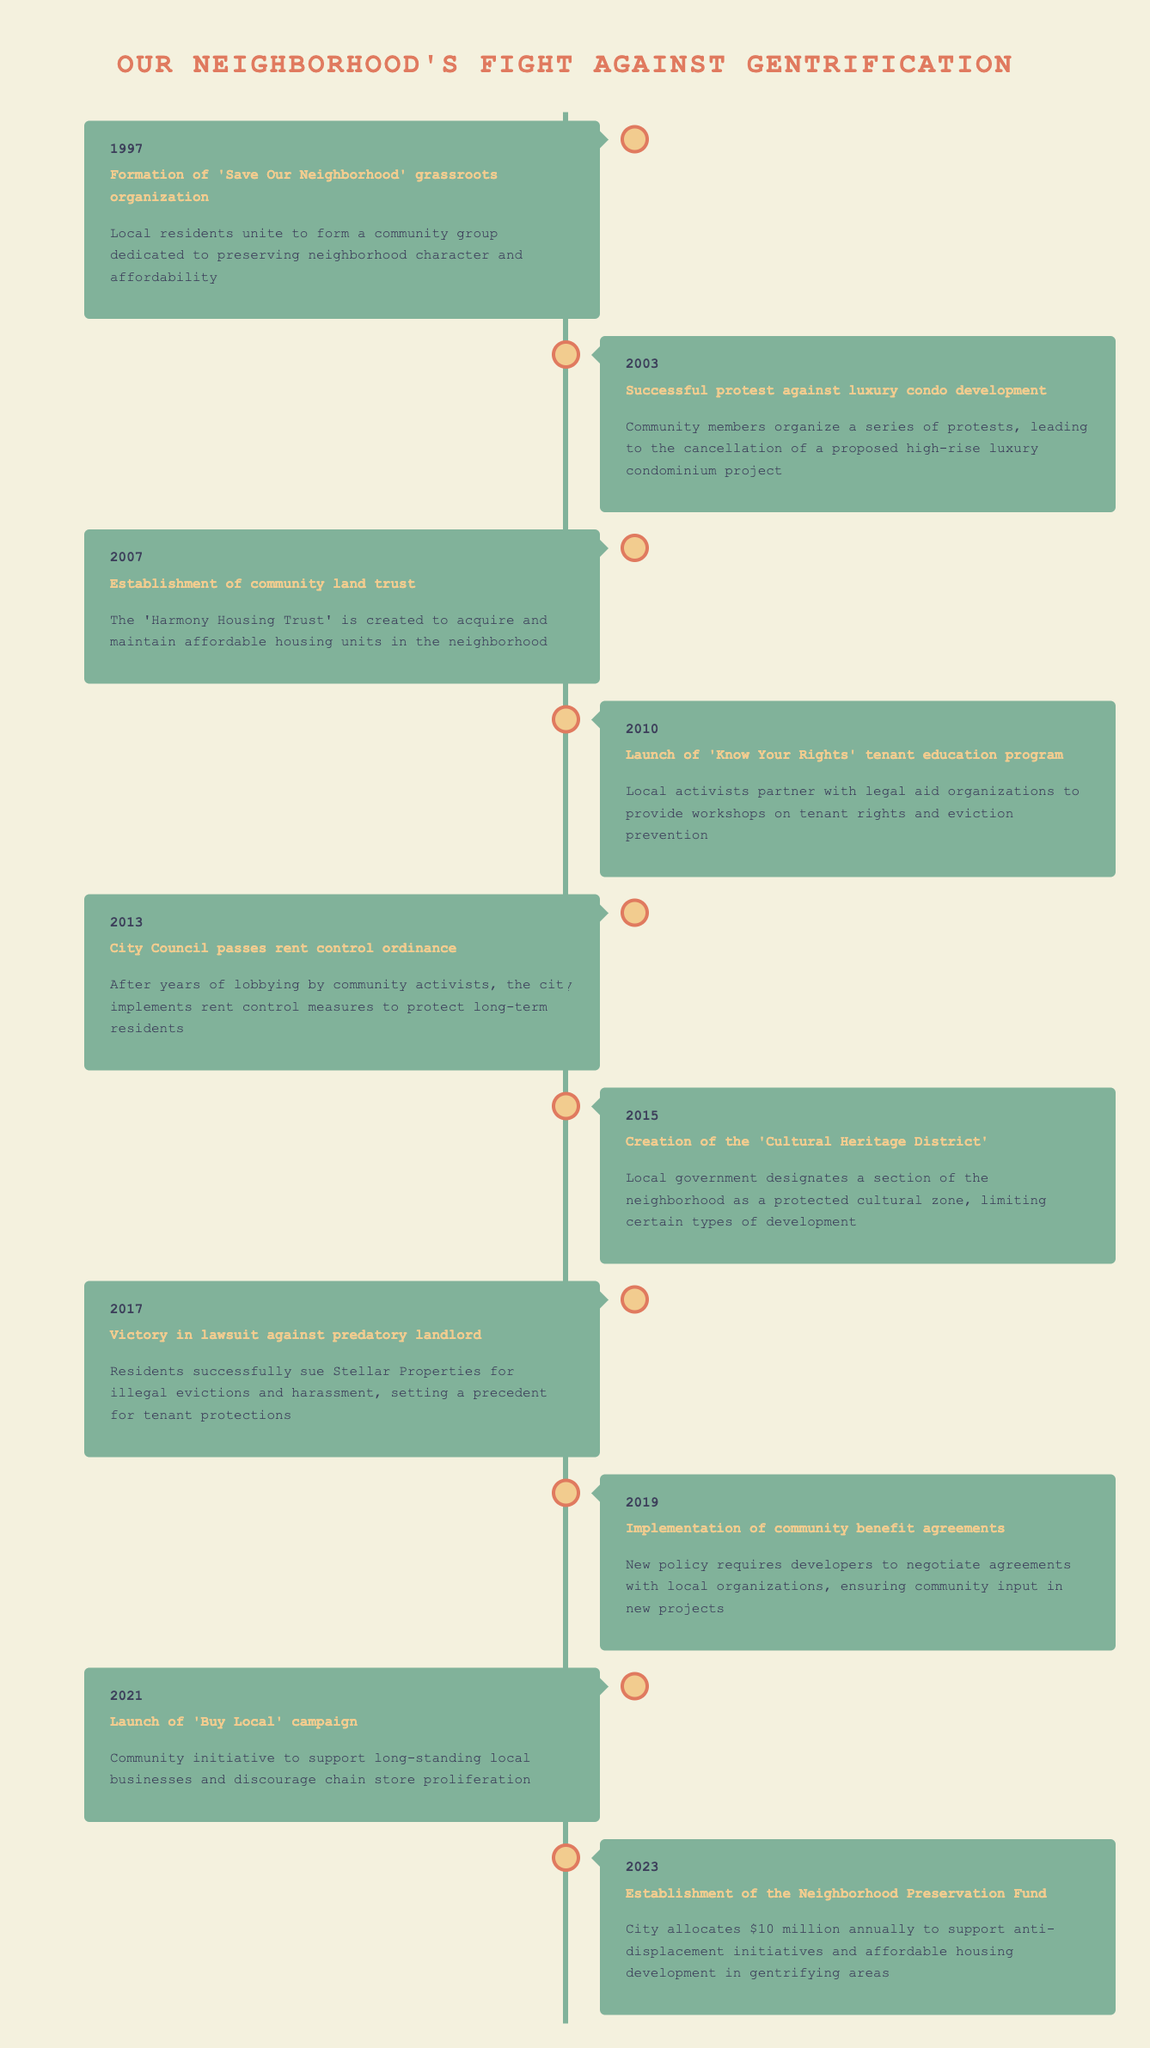What year was the 'Save Our Neighborhood' organization formed? According to the timeline, the 'Save Our Neighborhood' grassroots organization was formed in 1997.
Answer: 1997 How many events occurred during the 2010s? The timeline indicates that there were four events in the 2010s: 2010 (Launch of 'Know Your Rights' tenant education program), 2013 (City Council passes rent control ordinance), 2015 (Creation of the 'Cultural Heritage District'), and 2017 (Victory in lawsuit against predatory landlord).
Answer: 4 Is the establishment of the Neighborhood Preservation Fund a recent development? Yes, the establishment of the Neighborhood Preservation Fund occurred in 2023, which is the latest year mentioned in the timeline.
Answer: Yes Which event occurred first: the successful protest against luxury condo development or the launch of the 'Know Your Rights' tenant education program? The successful protest against luxury condo development occurred in 2003, while the launch of the 'Know Your Rights' tenant education program took place in 2010. Since 2003 is earlier than 2010, the protest occurred first.
Answer: Successful protest against luxury condo development What significant change regarding housing happened specifically in 2013? In 2013, the City Council passed a rent control ordinance aimed at protecting long-term residents as a result of lobbying by community activists. This was a significant legislative change impacting housing stability in the neighborhood.
Answer: City Council passes rent control ordinance What types of initiatives were introduced between 2019 and 2023? Between 2019 and 2023, two initiatives were introduced: the implementation of community benefit agreements in 2019, which requires developers to negotiate with local organizations, and the establishment of the Neighborhood Preservation Fund in 2023, which allocates funds for anti-displacement initiatives and affordable housing.
Answer: Community benefit agreements and Neighborhood Preservation Fund How many years passed between the formation of 'Save Our Neighborhood' and the establishment of the 'Harmony Housing Trust'? The 'Save Our Neighborhood' grassroots organization was formed in 1997, and the 'Harmony Housing Trust' was established in 2007. The difference in years is 2007 - 1997 = 10 years.
Answer: 10 years Was there an event related to legal tenant protections? Yes, in 2017, there was a victory in a lawsuit against a predatory landlord, where residents successfully sued for illegal evictions and harassment, which contributed to setting a precedent for tenant protections.
Answer: Yes 